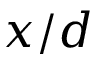<formula> <loc_0><loc_0><loc_500><loc_500>x / d</formula> 